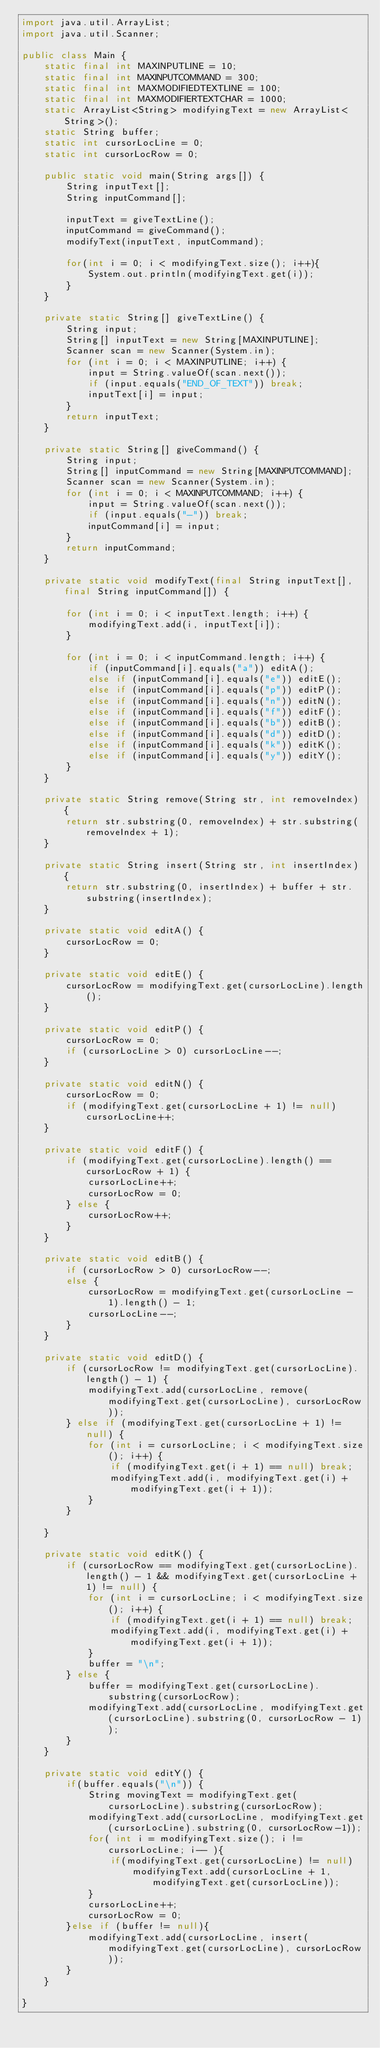Convert code to text. <code><loc_0><loc_0><loc_500><loc_500><_Java_>import java.util.ArrayList;
import java.util.Scanner;

public class Main {
    static final int MAXINPUTLINE = 10;
    static final int MAXINPUTCOMMAND = 300;
    static final int MAXMODIFIEDTEXTLINE = 100;
    static final int MAXMODIFIERTEXTCHAR = 1000;
    static ArrayList<String> modifyingText = new ArrayList<String>();
    static String buffer;
    static int cursorLocLine = 0;
    static int cursorLocRow = 0;

    public static void main(String args[]) {
        String inputText[];
        String inputCommand[];

        inputText = giveTextLine();
        inputCommand = giveCommand();
        modifyText(inputText, inputCommand);

        for(int i = 0; i < modifyingText.size(); i++){
            System.out.println(modifyingText.get(i));
        }
    }

    private static String[] giveTextLine() {
        String input;
        String[] inputText = new String[MAXINPUTLINE];
        Scanner scan = new Scanner(System.in);
        for (int i = 0; i < MAXINPUTLINE; i++) {
            input = String.valueOf(scan.next());
            if (input.equals("END_OF_TEXT")) break;
            inputText[i] = input;
        }
        return inputText;
    }

    private static String[] giveCommand() {
        String input;
        String[] inputCommand = new String[MAXINPUTCOMMAND];
        Scanner scan = new Scanner(System.in);
        for (int i = 0; i < MAXINPUTCOMMAND; i++) {
            input = String.valueOf(scan.next());
            if (input.equals("-")) break;
            inputCommand[i] = input;
        }
        return inputCommand;
    }

    private static void modifyText(final String inputText[], final String inputCommand[]) {

        for (int i = 0; i < inputText.length; i++) {
            modifyingText.add(i, inputText[i]);
        }

        for (int i = 0; i < inputCommand.length; i++) {
            if (inputCommand[i].equals("a")) editA();
            else if (inputCommand[i].equals("e")) editE();
            else if (inputCommand[i].equals("p")) editP();
            else if (inputCommand[i].equals("n")) editN();
            else if (inputCommand[i].equals("f")) editF();
            else if (inputCommand[i].equals("b")) editB();
            else if (inputCommand[i].equals("d")) editD();
            else if (inputCommand[i].equals("k")) editK();
            else if (inputCommand[i].equals("y")) editY();
        }
    }

    private static String remove(String str, int removeIndex) {
        return str.substring(0, removeIndex) + str.substring(removeIndex + 1);
    }

    private static String insert(String str, int insertIndex) {
        return str.substring(0, insertIndex) + buffer + str.substring(insertIndex);
    }

    private static void editA() {
        cursorLocRow = 0;
    }

    private static void editE() {
        cursorLocRow = modifyingText.get(cursorLocLine).length();
    }

    private static void editP() {
        cursorLocRow = 0;
        if (cursorLocLine > 0) cursorLocLine--;
    }

    private static void editN() {
        cursorLocRow = 0;
        if (modifyingText.get(cursorLocLine + 1) != null) cursorLocLine++;
    }

    private static void editF() {
        if (modifyingText.get(cursorLocLine).length() == cursorLocRow + 1) {
            cursorLocLine++;
            cursorLocRow = 0;
        } else {
            cursorLocRow++;
        }
    }

    private static void editB() {
        if (cursorLocRow > 0) cursorLocRow--;
        else {
            cursorLocRow = modifyingText.get(cursorLocLine - 1).length() - 1;
            cursorLocLine--;
        }
    }

    private static void editD() {
        if (cursorLocRow != modifyingText.get(cursorLocLine).length() - 1) {
            modifyingText.add(cursorLocLine, remove(modifyingText.get(cursorLocLine), cursorLocRow));
        } else if (modifyingText.get(cursorLocLine + 1) != null) {
            for (int i = cursorLocLine; i < modifyingText.size(); i++) {
                if (modifyingText.get(i + 1) == null) break;
                modifyingText.add(i, modifyingText.get(i) + modifyingText.get(i + 1));
            }
        }

    }

    private static void editK() {
        if (cursorLocRow == modifyingText.get(cursorLocLine).length() - 1 && modifyingText.get(cursorLocLine + 1) != null) {
            for (int i = cursorLocLine; i < modifyingText.size(); i++) {
                if (modifyingText.get(i + 1) == null) break;
                modifyingText.add(i, modifyingText.get(i) + modifyingText.get(i + 1));
            }
            buffer = "\n";
        } else {
            buffer = modifyingText.get(cursorLocLine).substring(cursorLocRow);
            modifyingText.add(cursorLocLine, modifyingText.get(cursorLocLine).substring(0, cursorLocRow - 1));
        }
    }

    private static void editY() {
        if(buffer.equals("\n")) {
            String movingText = modifyingText.get(cursorLocLine).substring(cursorLocRow);
            modifyingText.add(cursorLocLine, modifyingText.get(cursorLocLine).substring(0, cursorLocRow-1));
            for( int i = modifyingText.size(); i != cursorLocLine; i-- ){
                if(modifyingText.get(cursorLocLine) != null)
                    modifyingText.add(cursorLocLine + 1, modifyingText.get(cursorLocLine));
            }
            cursorLocLine++;
            cursorLocRow = 0;
        }else if (buffer != null){
            modifyingText.add(cursorLocLine, insert(modifyingText.get(cursorLocLine), cursorLocRow));
        }
    }

}
</code> 